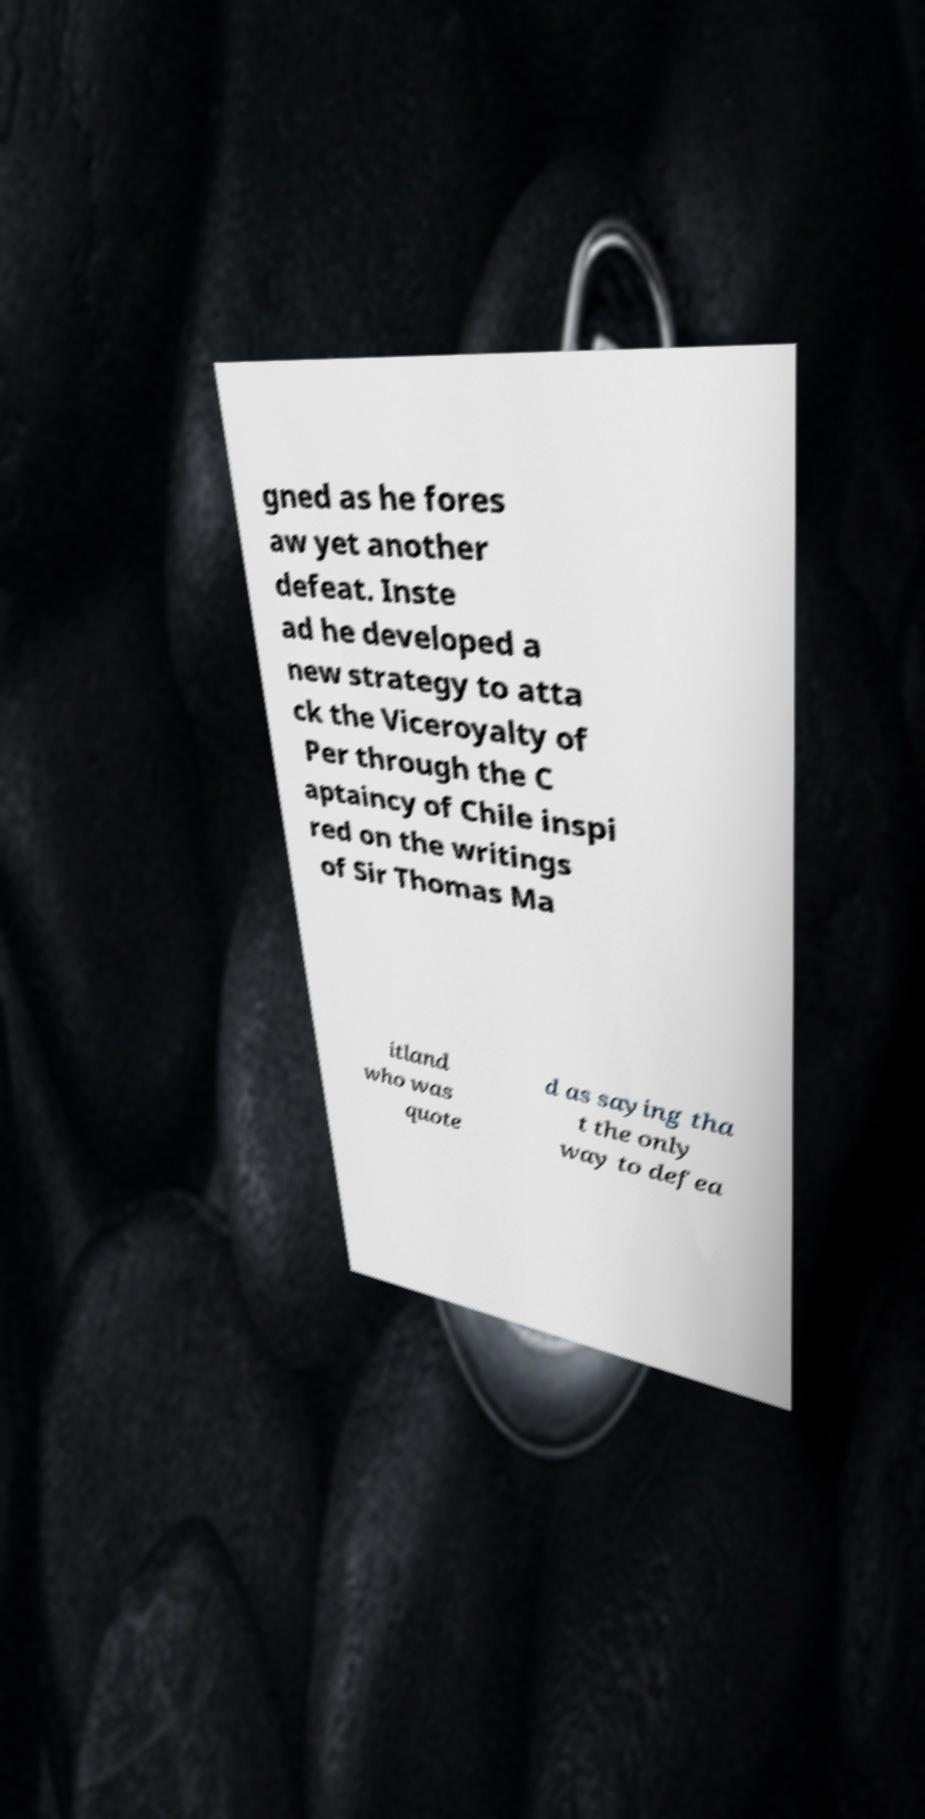For documentation purposes, I need the text within this image transcribed. Could you provide that? gned as he fores aw yet another defeat. Inste ad he developed a new strategy to atta ck the Viceroyalty of Per through the C aptaincy of Chile inspi red on the writings of Sir Thomas Ma itland who was quote d as saying tha t the only way to defea 